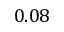<formula> <loc_0><loc_0><loc_500><loc_500>0 . 0 8</formula> 